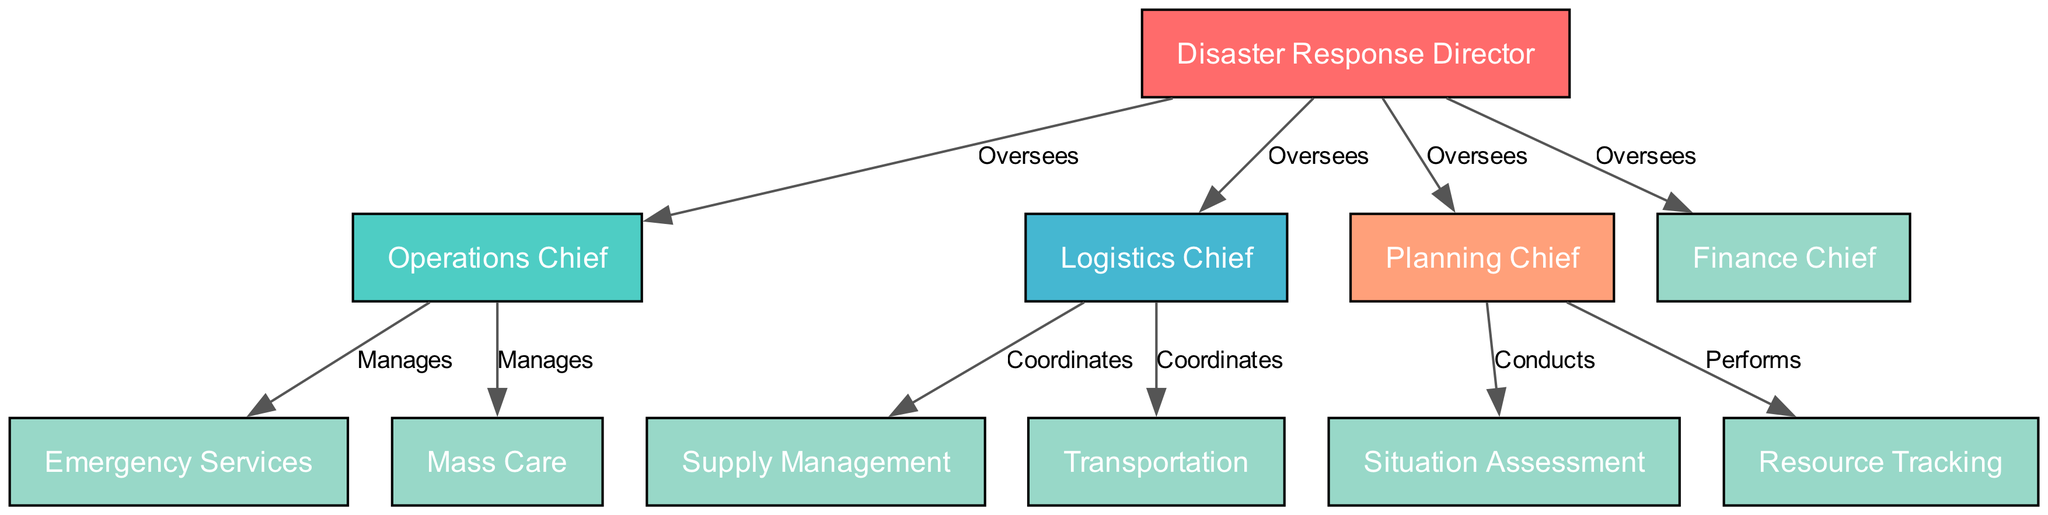What is the highest position in the Red Cross disaster response structure? The diagram indicates that the "Disaster Response Director" holds the highest position at the top of the organizational structure. There are no nodes above this one, making it the highest in rank.
Answer: Disaster Response Director How many nodes are present in the diagram? By counting the nodes listed in the given data, we find that there are 11 nodes in total, representing various roles within the disaster response team.
Answer: 11 Which role does the Operations Chief manage? According to the diagram's edges, the "Operations Chief" manages both "Emergency Services" and "Mass Care," as indicated by the "Manages" relationships directed towards these roles.
Answer: Emergency Services, Mass Care What is the relationship between the Disaster Response Director and the Planning Chief? The diagram illustrates that the "Disaster Response Director" oversees the "Planning Chief," indicating a supervisory relationship where the Director directs the activities of the Planning Chief.
Answer: Oversees How many roles are coordinated by the Logistics Chief? The "Logistics Chief" coordinates two roles according to the diagram: "Supply Management" and "Transportation", as shown by the directed edges labeled "Coordinates" leading from the Logistics Chief to these two positions.
Answer: 2 Which two functions are performed by the Planning Chief? The "Planning Chief" performs "Situation Assessment" and "Resource Tracking," as shown by the directed edges labeled "Conducts" and "Performs," connecting the Planning Chief to these respective roles in the diagram.
Answer: Situation Assessment, Resource Tracking Who directly oversees the Finance Chief? In the organizational structure illustrated in the diagram, the "Disaster Response Director" has an overseeing relationship with the "Finance Chief," meaning the Director is responsible for the Chief's actions.
Answer: Disaster Response Director What does the Logistics Chief coordinate with respect to resources? The diagram shows that the "Logistics Chief" coordinates the roles of "Supply Management" and "Transportation," indicating that these functions are managed under the Logistics Chief's responsibilities.
Answer: Supply Management, Transportation 